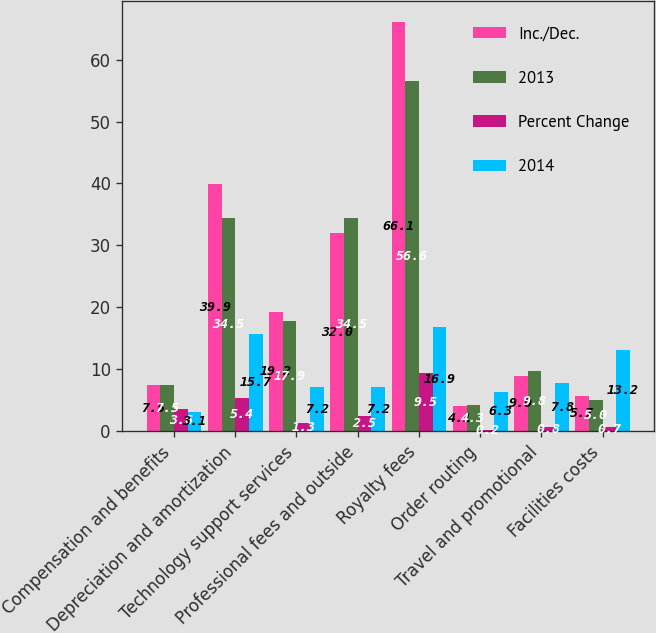<chart> <loc_0><loc_0><loc_500><loc_500><stacked_bar_chart><ecel><fcel>Compensation and benefits<fcel>Depreciation and amortization<fcel>Technology support services<fcel>Professional fees and outside<fcel>Royalty fees<fcel>Order routing<fcel>Travel and promotional<fcel>Facilities costs<nl><fcel>Inc./Dec.<fcel>7.5<fcel>39.9<fcel>19.2<fcel>32<fcel>66.1<fcel>4.1<fcel>9<fcel>5.7<nl><fcel>2013<fcel>7.5<fcel>34.5<fcel>17.9<fcel>34.5<fcel>56.6<fcel>4.3<fcel>9.8<fcel>5<nl><fcel>Percent Change<fcel>3.6<fcel>5.4<fcel>1.3<fcel>2.5<fcel>9.5<fcel>0.2<fcel>0.8<fcel>0.7<nl><fcel>2014<fcel>3.1<fcel>15.7<fcel>7.2<fcel>7.2<fcel>16.9<fcel>6.3<fcel>7.8<fcel>13.2<nl></chart> 